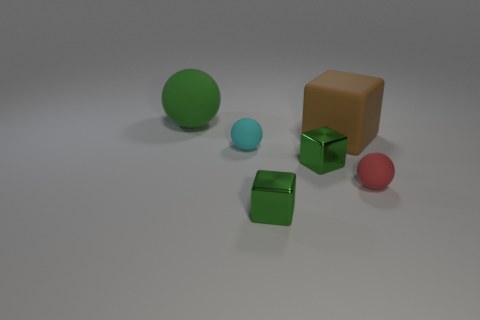Subtract all large brown matte cubes. How many cubes are left? 2 Subtract all green cubes. How many cubes are left? 1 Add 4 red metal cylinders. How many objects exist? 10 Subtract all big blue cylinders. Subtract all small cyan objects. How many objects are left? 5 Add 5 rubber things. How many rubber things are left? 9 Add 5 tiny cyan objects. How many tiny cyan objects exist? 6 Subtract 0 purple spheres. How many objects are left? 6 Subtract all green spheres. Subtract all green cylinders. How many spheres are left? 2 Subtract all blue cylinders. How many brown blocks are left? 1 